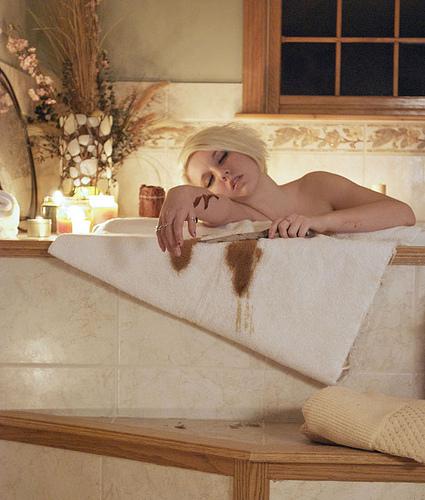What is on this women's arm?
Answer briefly. Blood. Is the woman asleep?
Quick response, please. Yes. Could this be a scene from a movie?
Keep it brief. Yes. 